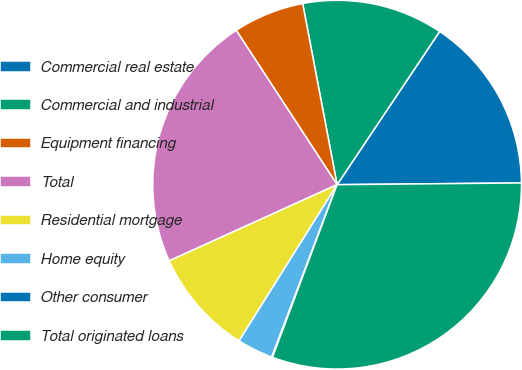Convert chart to OTSL. <chart><loc_0><loc_0><loc_500><loc_500><pie_chart><fcel>Commercial real estate<fcel>Commercial and industrial<fcel>Equipment financing<fcel>Total<fcel>Residential mortgage<fcel>Home equity<fcel>Other consumer<fcel>Total originated loans<nl><fcel>15.46%<fcel>12.38%<fcel>6.22%<fcel>22.57%<fcel>9.3%<fcel>3.15%<fcel>0.07%<fcel>30.85%<nl></chart> 